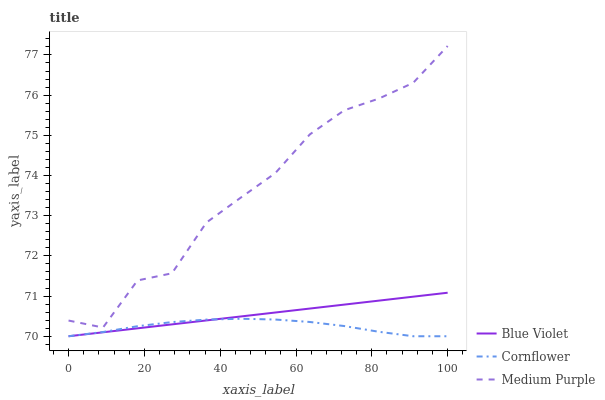Does Cornflower have the minimum area under the curve?
Answer yes or no. Yes. Does Medium Purple have the maximum area under the curve?
Answer yes or no. Yes. Does Blue Violet have the minimum area under the curve?
Answer yes or no. No. Does Blue Violet have the maximum area under the curve?
Answer yes or no. No. Is Blue Violet the smoothest?
Answer yes or no. Yes. Is Medium Purple the roughest?
Answer yes or no. Yes. Is Cornflower the smoothest?
Answer yes or no. No. Is Cornflower the roughest?
Answer yes or no. No. Does Medium Purple have the highest value?
Answer yes or no. Yes. Does Blue Violet have the highest value?
Answer yes or no. No. Is Cornflower less than Medium Purple?
Answer yes or no. Yes. Is Medium Purple greater than Blue Violet?
Answer yes or no. Yes. Does Blue Violet intersect Cornflower?
Answer yes or no. Yes. Is Blue Violet less than Cornflower?
Answer yes or no. No. Is Blue Violet greater than Cornflower?
Answer yes or no. No. Does Cornflower intersect Medium Purple?
Answer yes or no. No. 